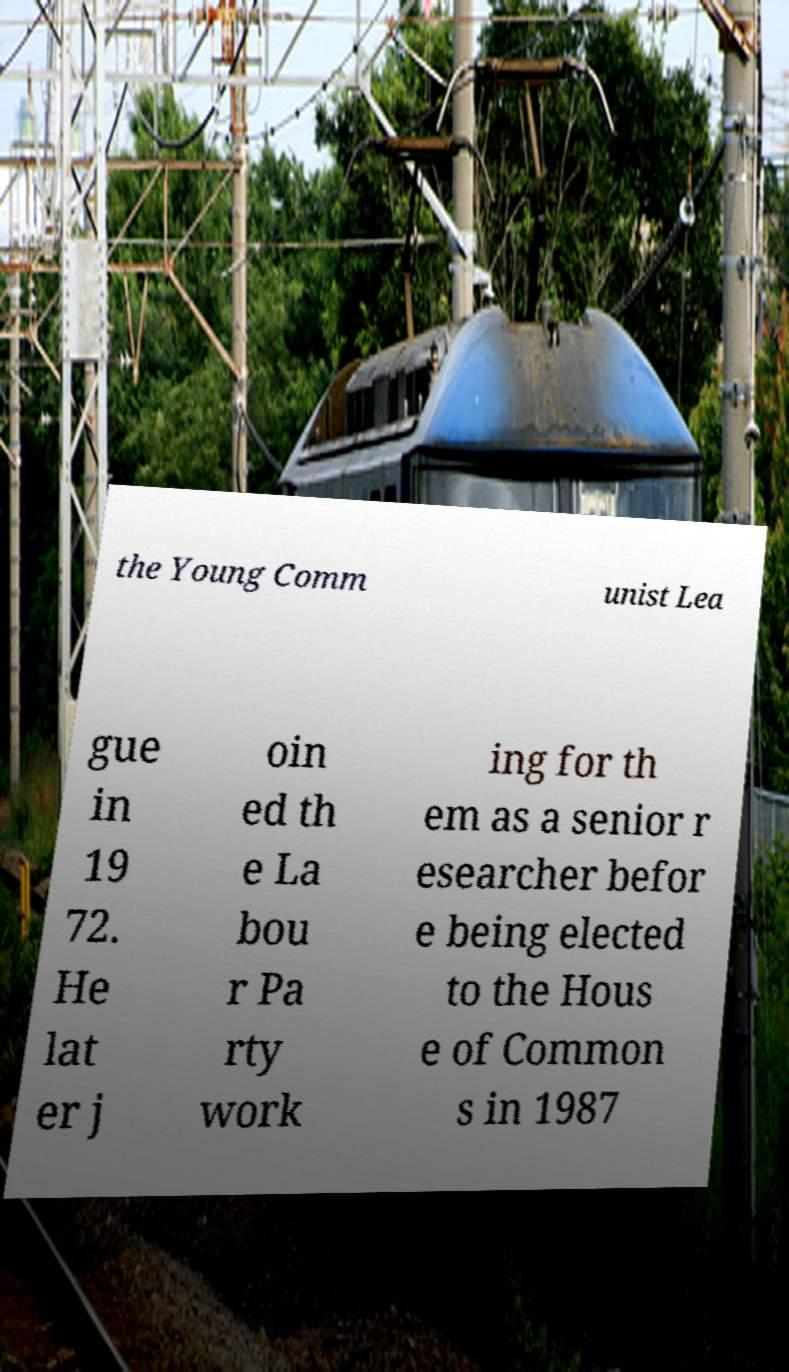Could you assist in decoding the text presented in this image and type it out clearly? the Young Comm unist Lea gue in 19 72. He lat er j oin ed th e La bou r Pa rty work ing for th em as a senior r esearcher befor e being elected to the Hous e of Common s in 1987 